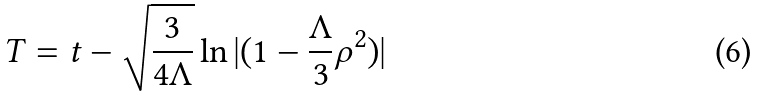Convert formula to latex. <formula><loc_0><loc_0><loc_500><loc_500>T = t - \sqrt { \frac { 3 } { 4 \Lambda } } \ln | ( 1 - \frac { \Lambda } { 3 } \rho ^ { 2 } ) |</formula> 